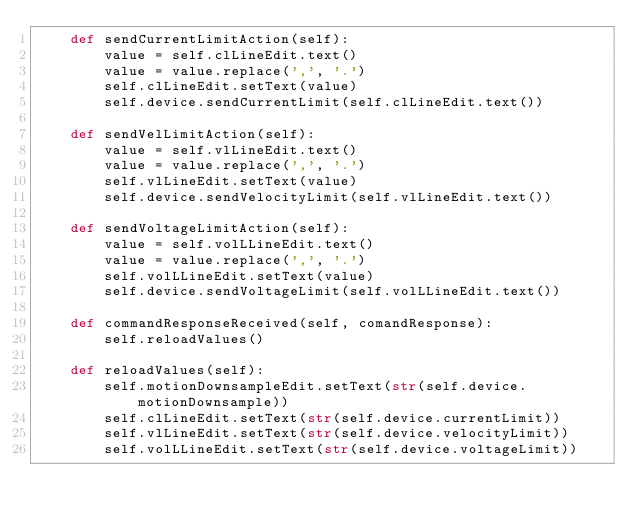Convert code to text. <code><loc_0><loc_0><loc_500><loc_500><_Python_>    def sendCurrentLimitAction(self):
        value = self.clLineEdit.text()
        value = value.replace(',', '.')
        self.clLineEdit.setText(value)
        self.device.sendCurrentLimit(self.clLineEdit.text())

    def sendVelLimitAction(self):
        value = self.vlLineEdit.text()
        value = value.replace(',', '.')
        self.vlLineEdit.setText(value)
        self.device.sendVelocityLimit(self.vlLineEdit.text())

    def sendVoltageLimitAction(self):
        value = self.volLLineEdit.text()
        value = value.replace(',', '.')
        self.volLLineEdit.setText(value)
        self.device.sendVoltageLimit(self.volLLineEdit.text())

    def commandResponseReceived(self, comandResponse):
        self.reloadValues()
        
    def reloadValues(self):
        self.motionDownsampleEdit.setText(str(self.device.motionDownsample))
        self.clLineEdit.setText(str(self.device.currentLimit))
        self.vlLineEdit.setText(str(self.device.velocityLimit))
        self.volLLineEdit.setText(str(self.device.voltageLimit))</code> 